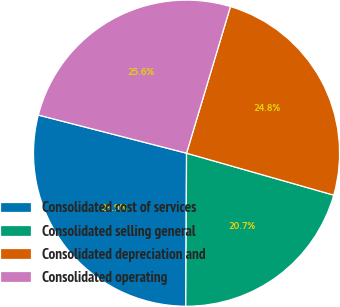<chart> <loc_0><loc_0><loc_500><loc_500><pie_chart><fcel>Consolidated cost of services<fcel>Consolidated selling general<fcel>Consolidated depreciation and<fcel>Consolidated operating<nl><fcel>28.93%<fcel>20.66%<fcel>24.79%<fcel>25.62%<nl></chart> 